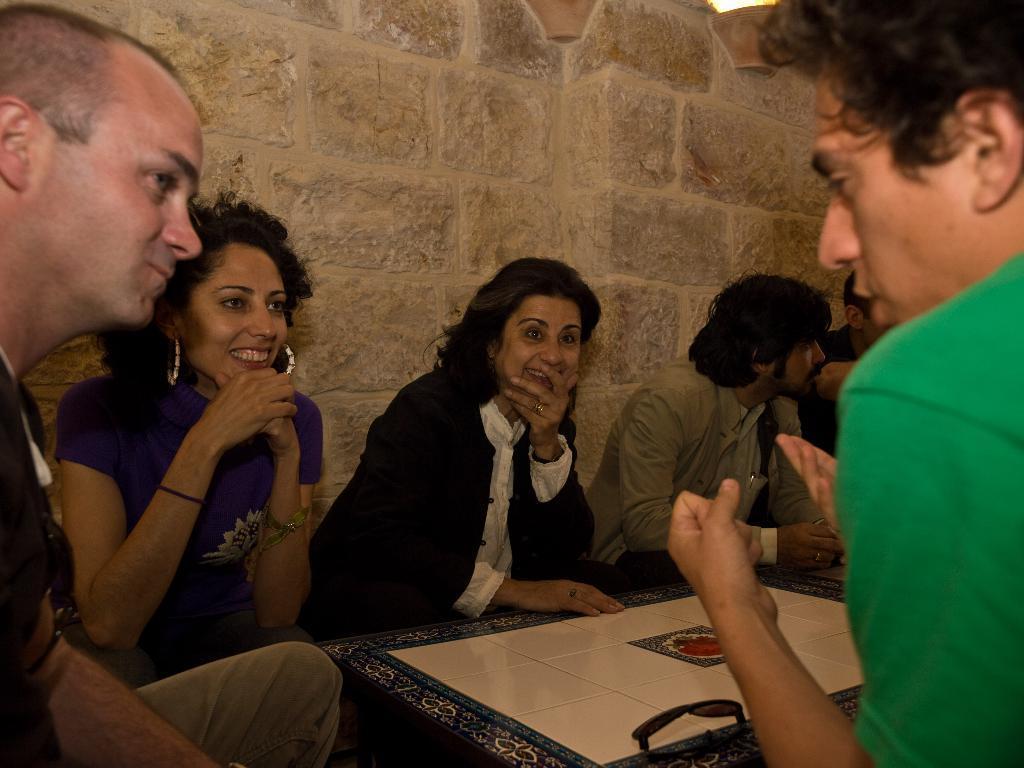Please provide a concise description of this image. in this picture there is a carrom board on the right side of the image and there are people those who are sitting around it, it seems to be they are playing. 